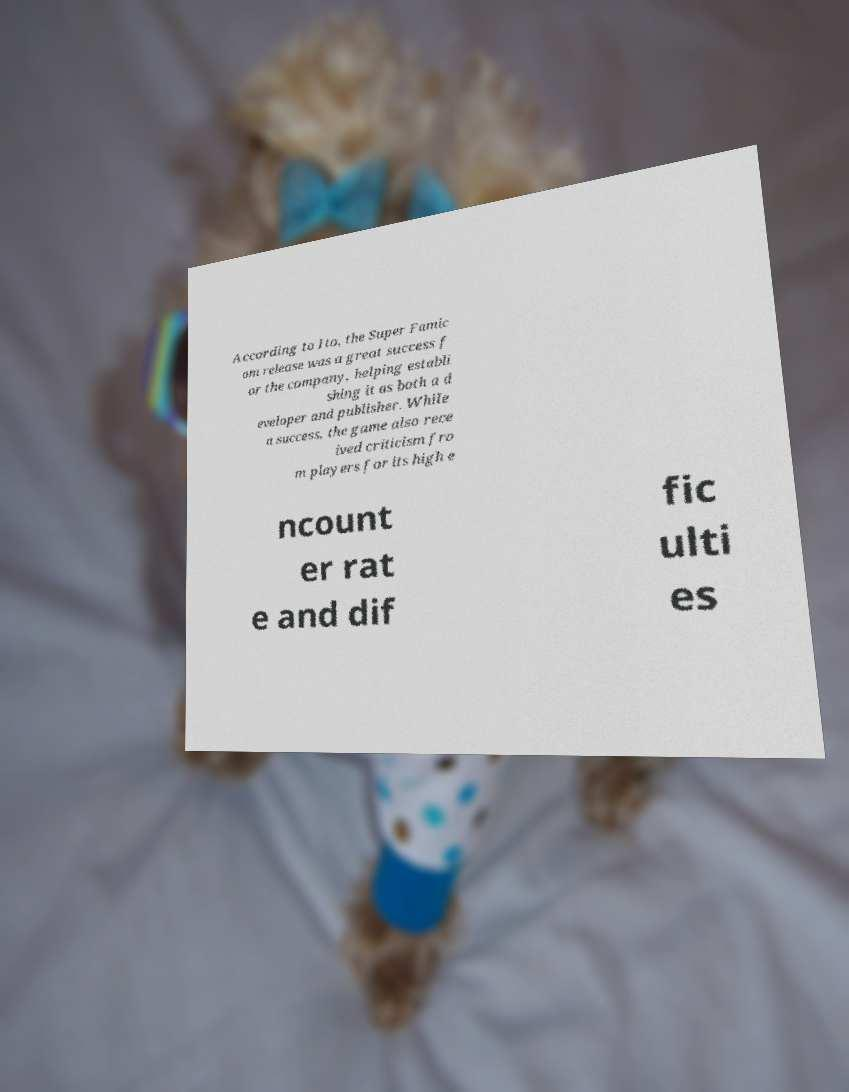Can you accurately transcribe the text from the provided image for me? According to Ito, the Super Famic om release was a great success f or the company, helping establi shing it as both a d eveloper and publisher. While a success, the game also rece ived criticism fro m players for its high e ncount er rat e and dif fic ulti es 